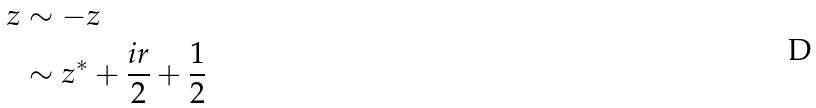Convert formula to latex. <formula><loc_0><loc_0><loc_500><loc_500>z & \sim - z \\ & \sim z ^ { * } + \frac { i r } { 2 } + \frac { 1 } { 2 }</formula> 